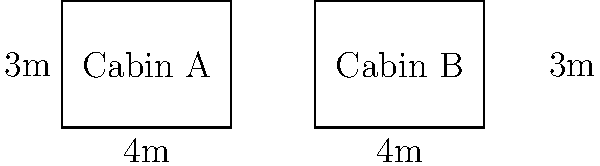As a boat trip planner, you're comparing two cabin floor plans on different boat models. Cabin A and Cabin B both have rectangular shapes with the same dimensions: 4 meters long and 3 meters wide. Are these cabin floor plans congruent? If so, explain which congruence criterion applies. To determine if the two cabin floor plans are congruent, we need to follow these steps:

1. Definition of congruence: Two geometric figures are congruent if they have the same shape and size.

2. Analyze the given information:
   - Both cabins have rectangular shapes
   - Cabin A dimensions: 4 meters long and 3 meters wide
   - Cabin B dimensions: 4 meters long and 3 meters wide

3. Compare the dimensions:
   - Length of Cabin A = Length of Cabin B = 4 meters
   - Width of Cabin A = Width of Cabin B = 3 meters

4. Congruence criteria for rectangles:
   - Two rectangles are congruent if they have the same length and width

5. Apply the congruence criterion:
   Since both cabins have the same length (4 meters) and the same width (3 meters), they satisfy the congruence criterion for rectangles.

6. Determine the specific congruence criterion:
   In this case, we are using the Side-Side (SS) criterion for rectangle congruence. This criterion states that if two rectangles have the same length and width, they are congruent.

Therefore, Cabin A and Cabin B are congruent based on the Side-Side (SS) criterion for rectangle congruence.
Answer: Yes, congruent; Side-Side (SS) criterion 